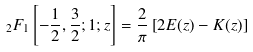<formula> <loc_0><loc_0><loc_500><loc_500>\ _ { 2 } F _ { 1 } \left [ - \frac { 1 } { 2 } , \frac { 3 } { 2 } ; 1 ; z \right ] = \frac { 2 } { \pi } \left [ 2 E ( z ) - K ( z ) \right ]</formula> 